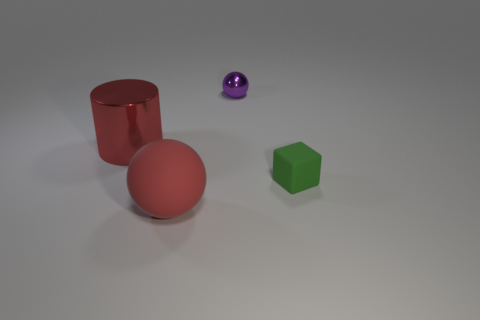There is a sphere on the right side of the red rubber ball; what is its color? The sphere located to the right of the red rubber ball in the image is purple. It has a slightly reflective surface, casting a modest gleam and revealing subtle shades within its color. 